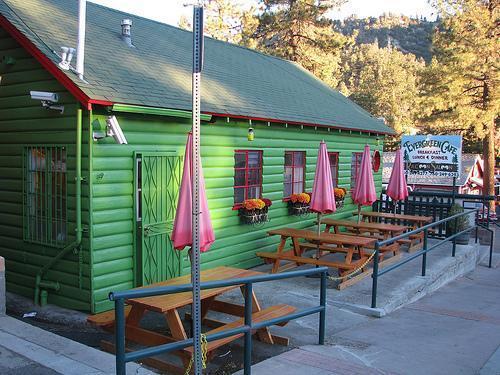How many umbrellas are in the image?
Give a very brief answer. 4. 